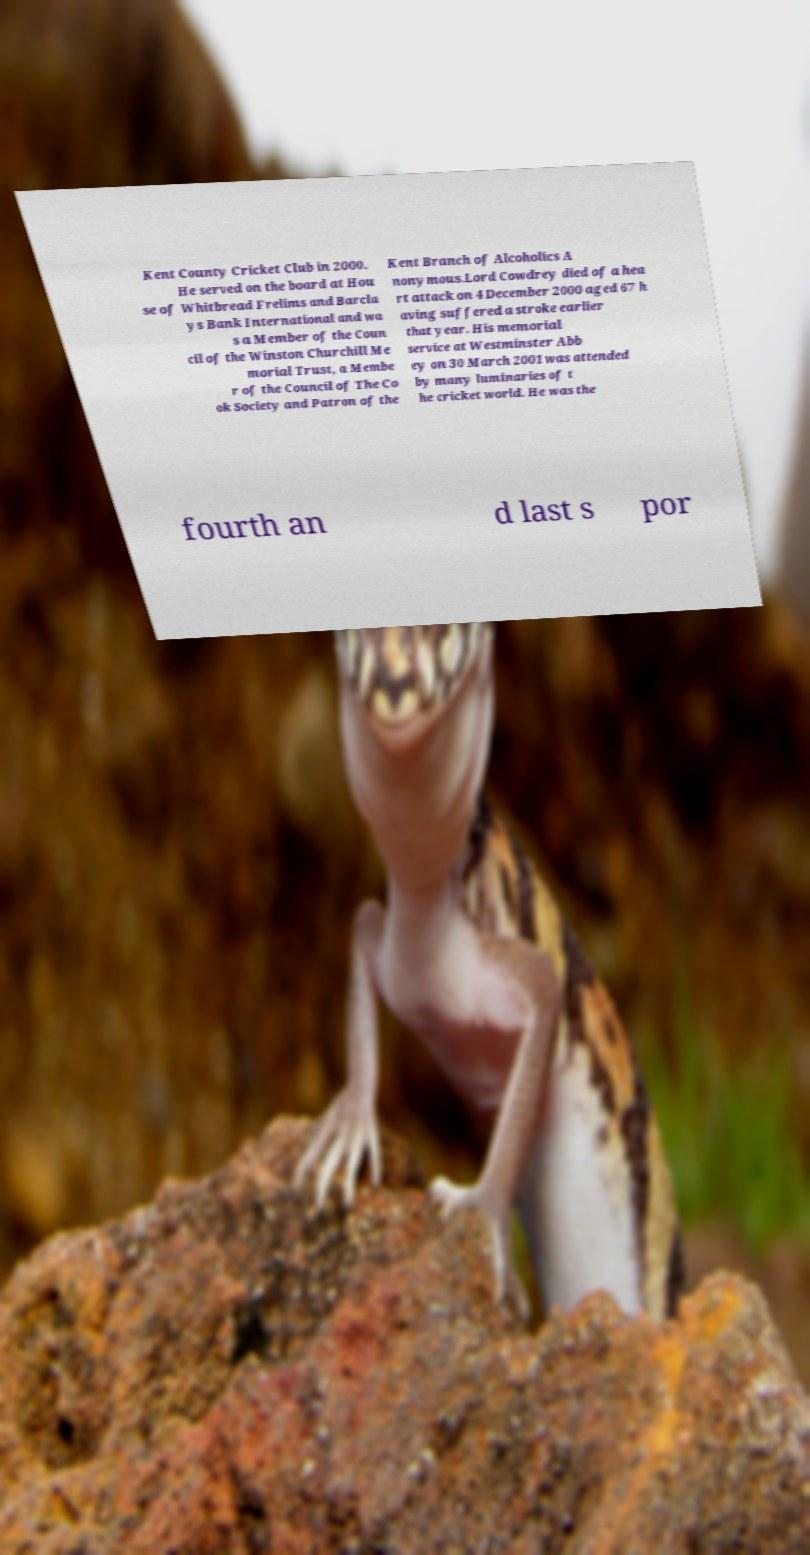Can you read and provide the text displayed in the image?This photo seems to have some interesting text. Can you extract and type it out for me? Kent County Cricket Club in 2000. He served on the board at Hou se of Whitbread Frelims and Barcla ys Bank International and wa s a Member of the Coun cil of the Winston Churchill Me morial Trust, a Membe r of the Council of The Co ok Society and Patron of the Kent Branch of Alcoholics A nonymous.Lord Cowdrey died of a hea rt attack on 4 December 2000 aged 67 h aving suffered a stroke earlier that year. His memorial service at Westminster Abb ey on 30 March 2001 was attended by many luminaries of t he cricket world. He was the fourth an d last s por 